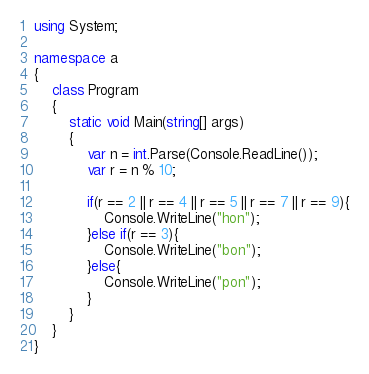Convert code to text. <code><loc_0><loc_0><loc_500><loc_500><_C#_>using System;

namespace a
{
    class Program
    {
        static void Main(string[] args)
        {
            var n = int.Parse(Console.ReadLine());
            var r = n % 10;

            if(r == 2 || r == 4 || r == 5 || r == 7 || r == 9){
                Console.WriteLine("hon");
            }else if(r == 3){
                Console.WriteLine("bon");
            }else{
                Console.WriteLine("pon");
            }
        }
    }
}
</code> 